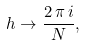Convert formula to latex. <formula><loc_0><loc_0><loc_500><loc_500>h \to \frac { 2 \, \pi \, i } { N } ,</formula> 